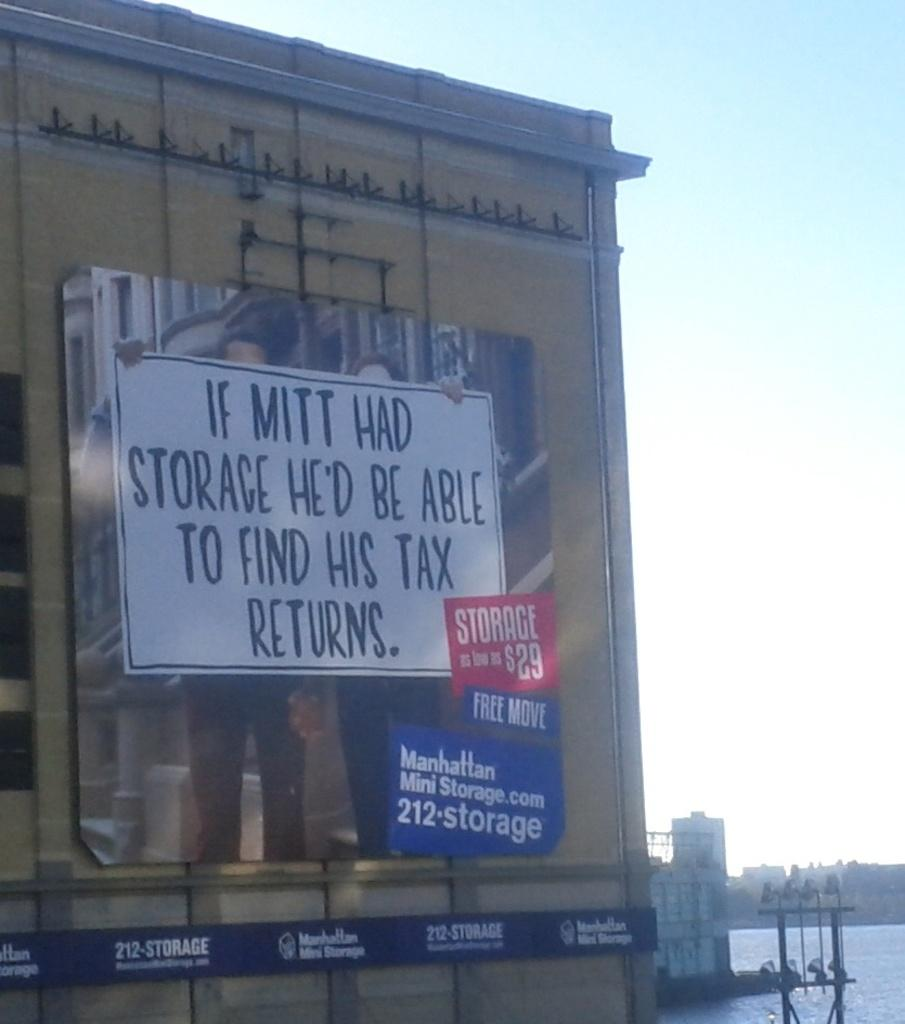<image>
Write a terse but informative summary of the picture. A storage facility advertisement with prices starting at $29 